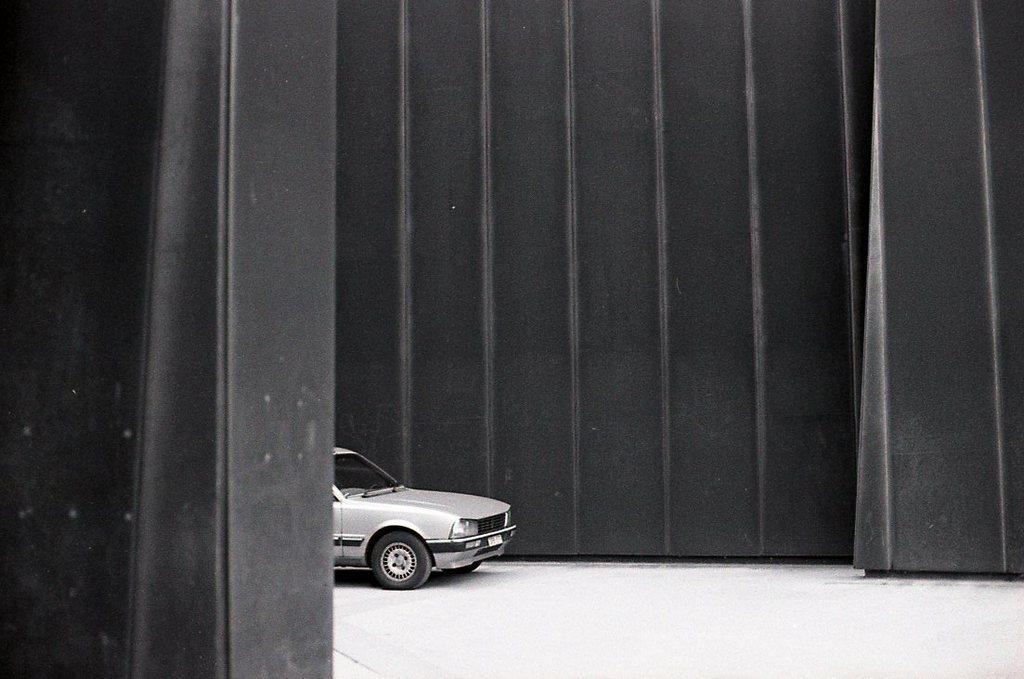How would you summarize this image in a sentence or two? In this picture we can observe a car on the floor. We can observe a black color wall in the background. This is a black and white image. 